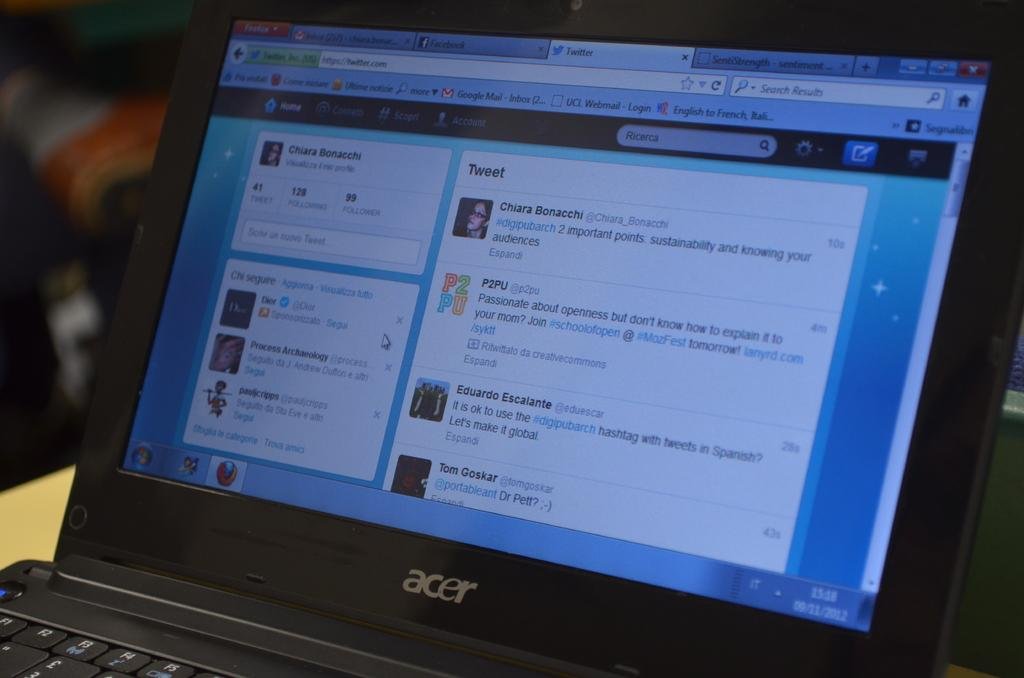Provide a one-sentence caption for the provided image. An Acer laptop, currently running a web browser displaying Twitter. 